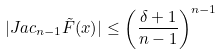Convert formula to latex. <formula><loc_0><loc_0><loc_500><loc_500>| J a c _ { n - 1 } \tilde { F } ( x ) | \leq \left ( \frac { \delta + 1 } { n - 1 } \right ) ^ { n - 1 }</formula> 